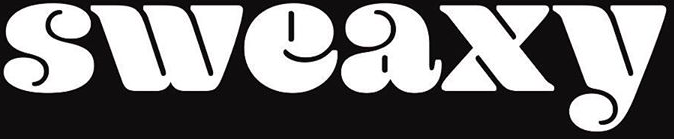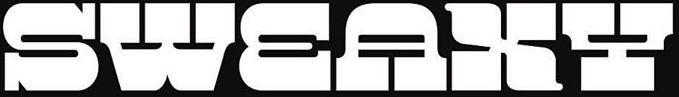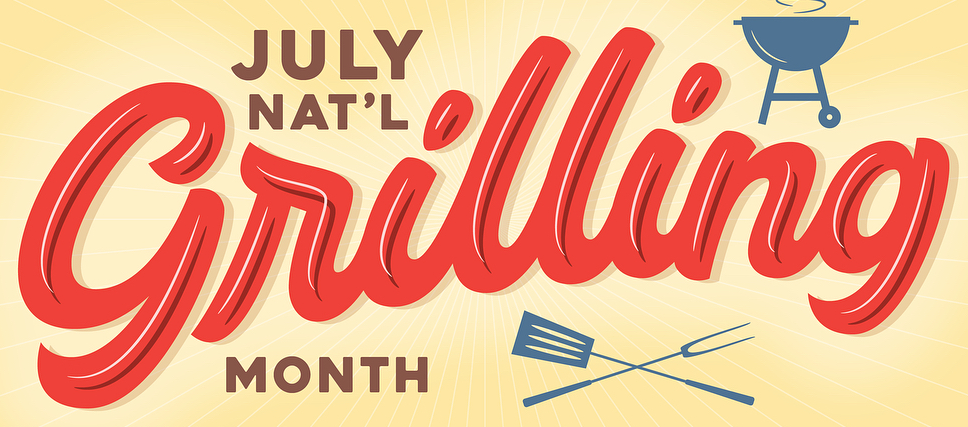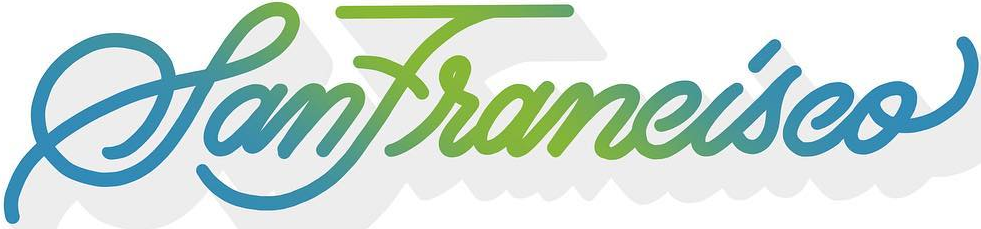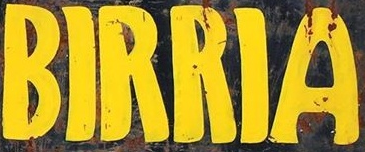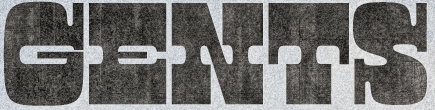Read the text from these images in sequence, separated by a semicolon. sweaxy; SWEAXY; Grilling; SanFrancisco; BIRRIA; GENTS 